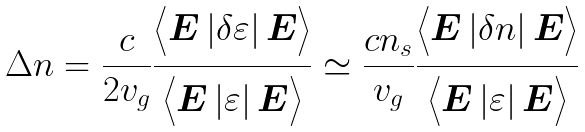Convert formula to latex. <formula><loc_0><loc_0><loc_500><loc_500>\Delta n = \frac { c } { 2 v _ { g } } \frac { \Big < { \boldsymbol E } \left | \delta \varepsilon \right | { \boldsymbol E } \Big > } { \Big < { \boldsymbol E } \left | \varepsilon \right | { \boldsymbol E } \Big > } \simeq \frac { c n _ { s } } { v _ { g } } \frac { \Big < { \boldsymbol E } \left | \delta n \right | { \boldsymbol E } \Big > } { \Big < { \boldsymbol E } \left | \varepsilon \right | { \boldsymbol E } \Big > }</formula> 